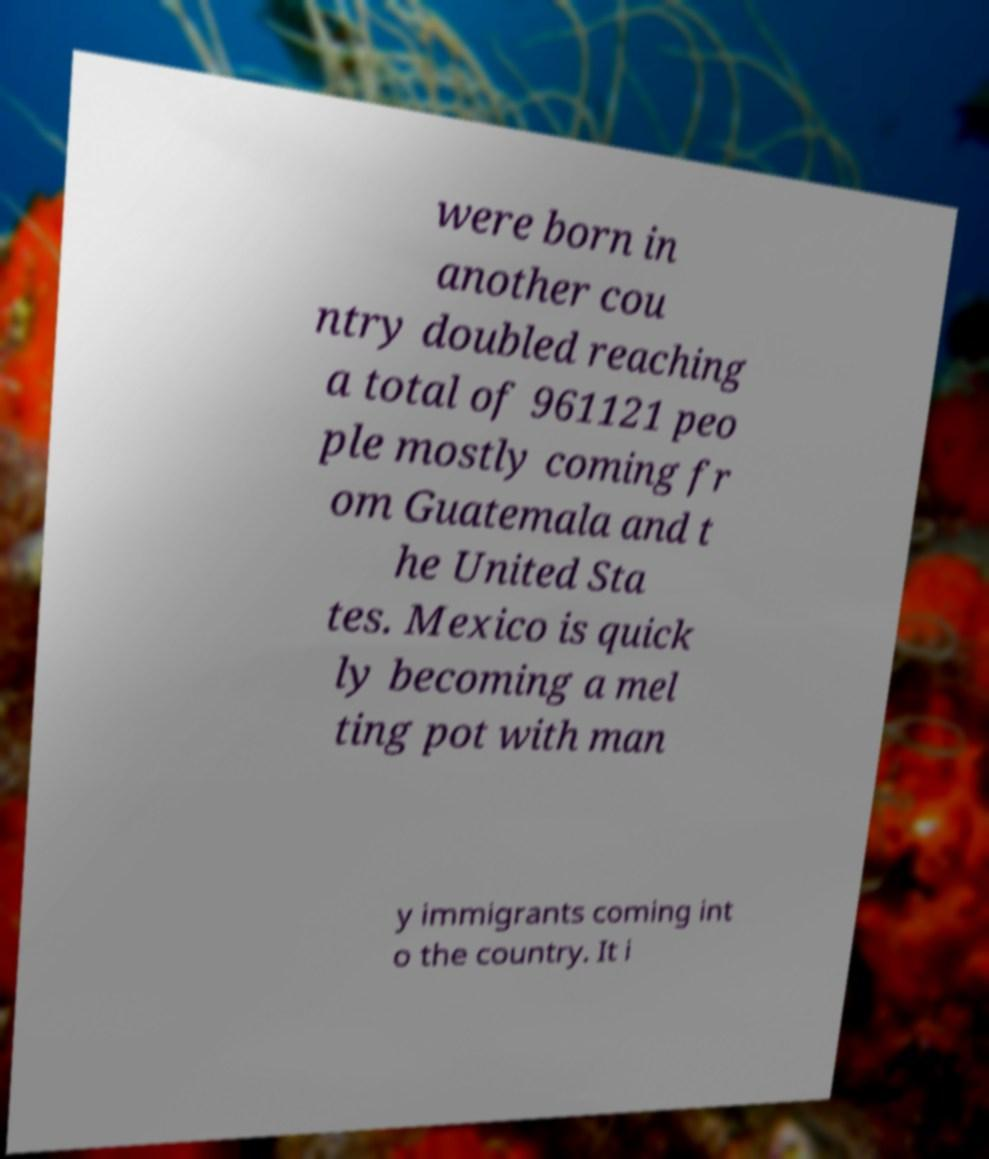Can you accurately transcribe the text from the provided image for me? were born in another cou ntry doubled reaching a total of 961121 peo ple mostly coming fr om Guatemala and t he United Sta tes. Mexico is quick ly becoming a mel ting pot with man y immigrants coming int o the country. It i 